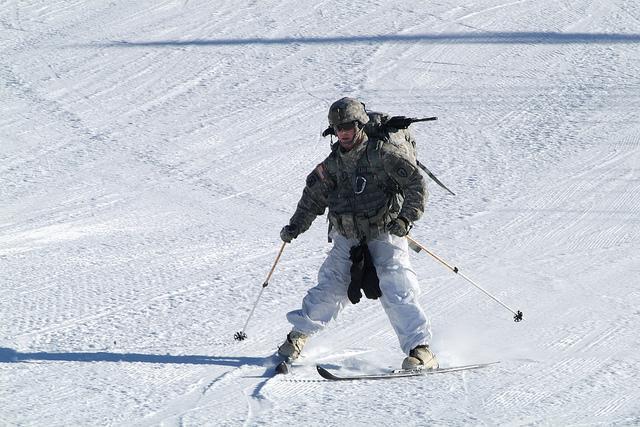How many black cats are there in the image ?
Give a very brief answer. 0. 